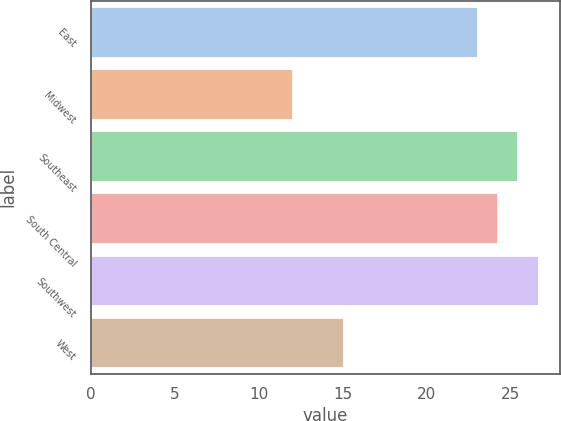Convert chart. <chart><loc_0><loc_0><loc_500><loc_500><bar_chart><fcel>East<fcel>Midwest<fcel>Southeast<fcel>South Central<fcel>Southwest<fcel>West<nl><fcel>23<fcel>12<fcel>25.4<fcel>24.2<fcel>26.6<fcel>15<nl></chart> 